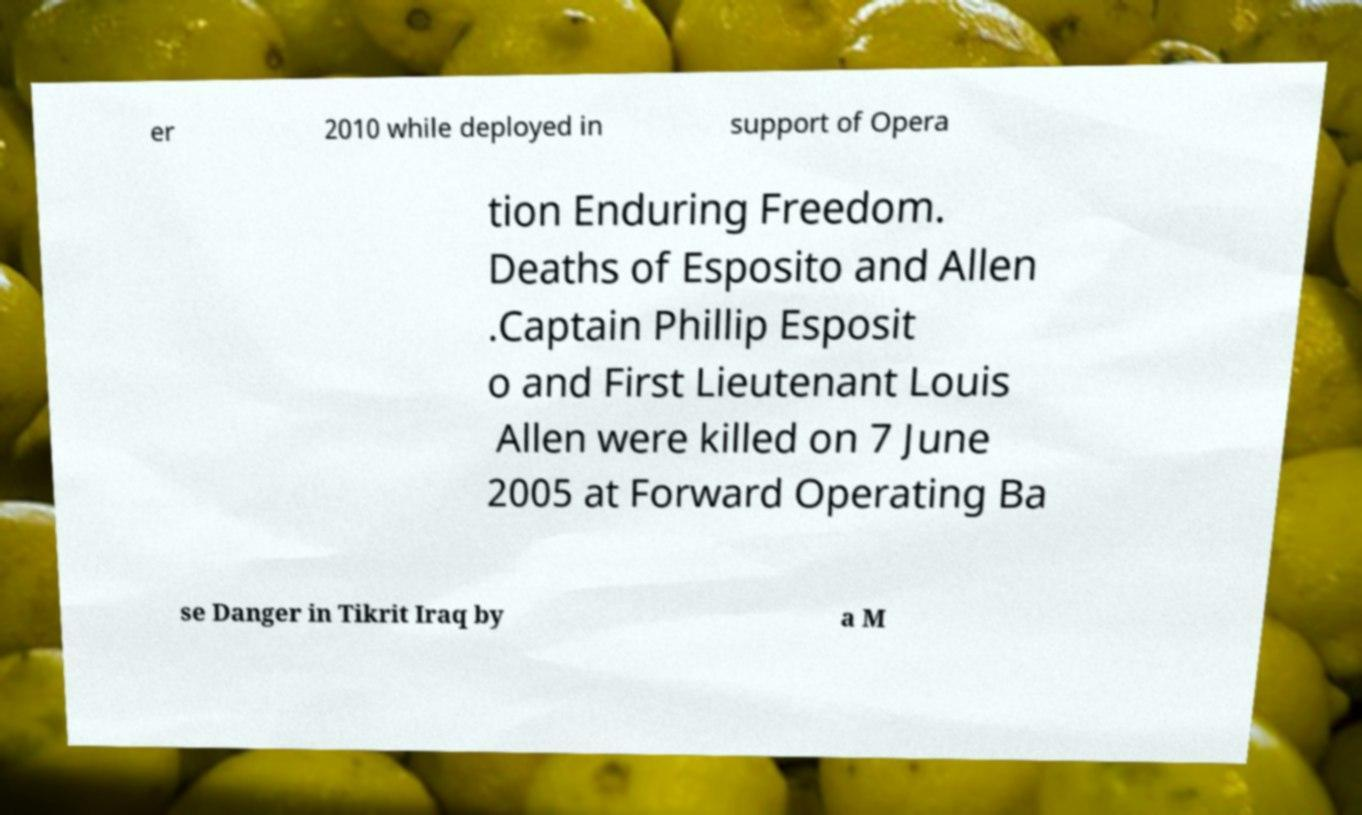There's text embedded in this image that I need extracted. Can you transcribe it verbatim? er 2010 while deployed in support of Opera tion Enduring Freedom. Deaths of Esposito and Allen .Captain Phillip Esposit o and First Lieutenant Louis Allen were killed on 7 June 2005 at Forward Operating Ba se Danger in Tikrit Iraq by a M 